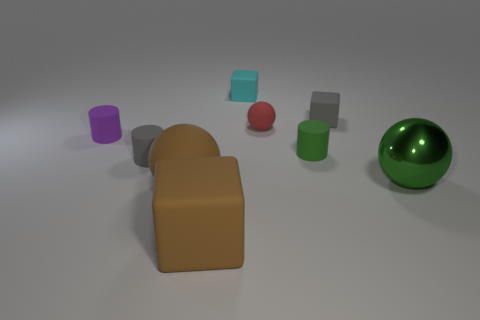What shape is the small thing that is the same color as the large shiny sphere?
Make the answer very short. Cylinder. Is the material of the small green cylinder the same as the tiny gray cube?
Provide a short and direct response. Yes. What number of other things are the same size as the brown rubber block?
Ensure brevity in your answer.  2. The large object that is on the right side of the gray cube that is behind the green matte cylinder is what color?
Your answer should be very brief. Green. What number of other objects are there of the same shape as the small purple object?
Provide a succinct answer. 2. Are there any small red spheres made of the same material as the red thing?
Ensure brevity in your answer.  No. There is another ball that is the same size as the brown ball; what is it made of?
Ensure brevity in your answer.  Metal. What color is the rubber sphere that is behind the matte ball in front of the gray object that is in front of the tiny green rubber cylinder?
Keep it short and to the point. Red. Is the shape of the small gray rubber object that is in front of the small green matte cylinder the same as the green object right of the small green cylinder?
Keep it short and to the point. No. How many red spheres are there?
Your answer should be compact. 1. 